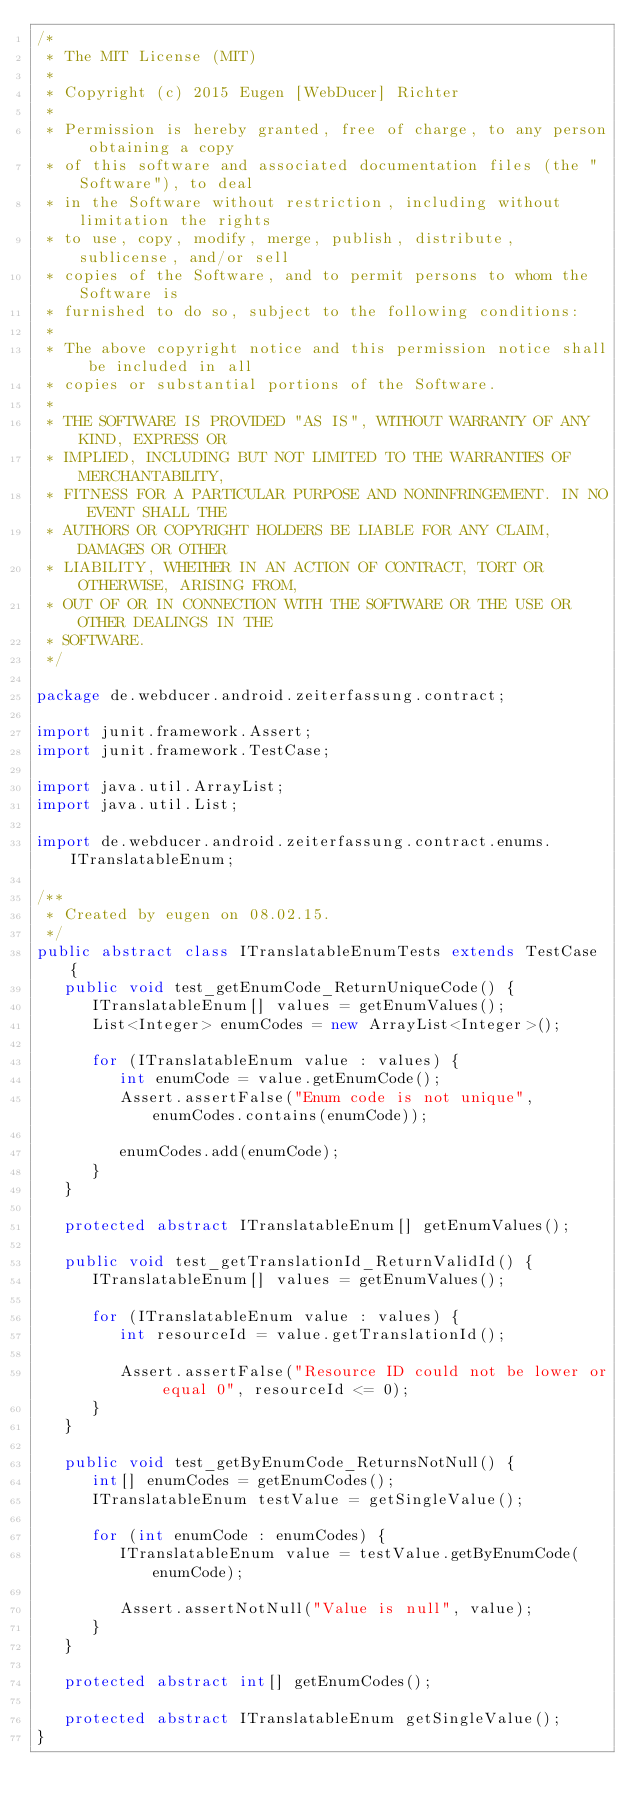<code> <loc_0><loc_0><loc_500><loc_500><_Java_>/*
 * The MIT License (MIT)
 *
 * Copyright (c) 2015 Eugen [WebDucer] Richter
 *
 * Permission is hereby granted, free of charge, to any person obtaining a copy
 * of this software and associated documentation files (the "Software"), to deal
 * in the Software without restriction, including without limitation the rights
 * to use, copy, modify, merge, publish, distribute, sublicense, and/or sell
 * copies of the Software, and to permit persons to whom the Software is
 * furnished to do so, subject to the following conditions:
 *
 * The above copyright notice and this permission notice shall be included in all
 * copies or substantial portions of the Software.
 *
 * THE SOFTWARE IS PROVIDED "AS IS", WITHOUT WARRANTY OF ANY KIND, EXPRESS OR
 * IMPLIED, INCLUDING BUT NOT LIMITED TO THE WARRANTIES OF MERCHANTABILITY,
 * FITNESS FOR A PARTICULAR PURPOSE AND NONINFRINGEMENT. IN NO EVENT SHALL THE
 * AUTHORS OR COPYRIGHT HOLDERS BE LIABLE FOR ANY CLAIM, DAMAGES OR OTHER
 * LIABILITY, WHETHER IN AN ACTION OF CONTRACT, TORT OR OTHERWISE, ARISING FROM,
 * OUT OF OR IN CONNECTION WITH THE SOFTWARE OR THE USE OR OTHER DEALINGS IN THE
 * SOFTWARE.
 */

package de.webducer.android.zeiterfassung.contract;

import junit.framework.Assert;
import junit.framework.TestCase;

import java.util.ArrayList;
import java.util.List;

import de.webducer.android.zeiterfassung.contract.enums.ITranslatableEnum;

/**
 * Created by eugen on 08.02.15.
 */
public abstract class ITranslatableEnumTests extends TestCase {
   public void test_getEnumCode_ReturnUniqueCode() {
      ITranslatableEnum[] values = getEnumValues();
      List<Integer> enumCodes = new ArrayList<Integer>();

      for (ITranslatableEnum value : values) {
         int enumCode = value.getEnumCode();
         Assert.assertFalse("Enum code is not unique", enumCodes.contains(enumCode));

         enumCodes.add(enumCode);
      }
   }

   protected abstract ITranslatableEnum[] getEnumValues();

   public void test_getTranslationId_ReturnValidId() {
      ITranslatableEnum[] values = getEnumValues();

      for (ITranslatableEnum value : values) {
         int resourceId = value.getTranslationId();

         Assert.assertFalse("Resource ID could not be lower or equal 0", resourceId <= 0);
      }
   }

   public void test_getByEnumCode_ReturnsNotNull() {
      int[] enumCodes = getEnumCodes();
      ITranslatableEnum testValue = getSingleValue();

      for (int enumCode : enumCodes) {
         ITranslatableEnum value = testValue.getByEnumCode(enumCode);

         Assert.assertNotNull("Value is null", value);
      }
   }

   protected abstract int[] getEnumCodes();

   protected abstract ITranslatableEnum getSingleValue();
}
</code> 